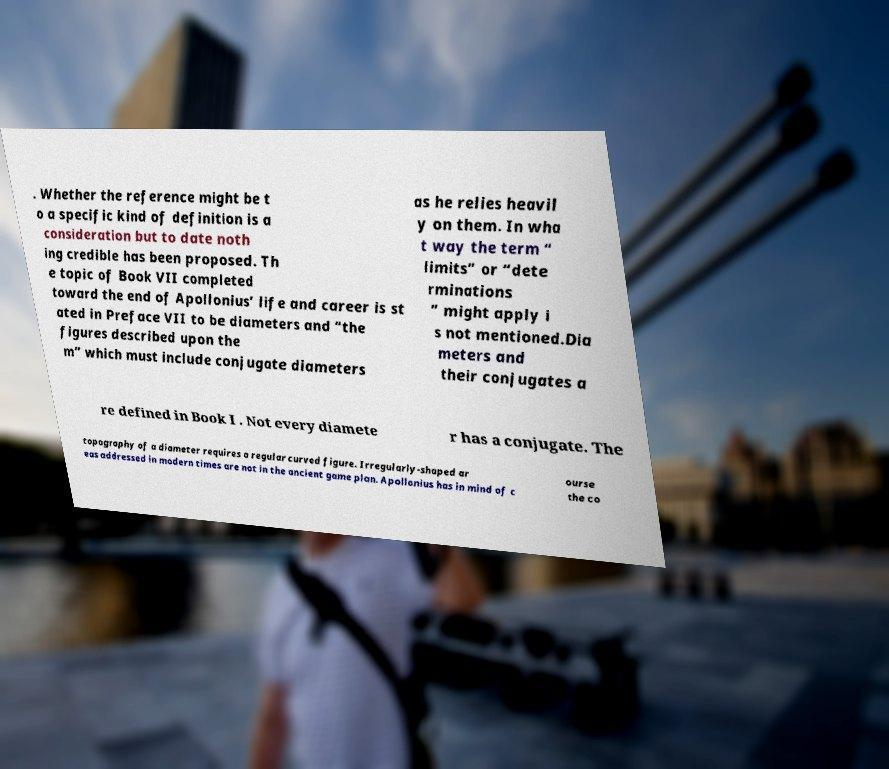Can you accurately transcribe the text from the provided image for me? . Whether the reference might be t o a specific kind of definition is a consideration but to date noth ing credible has been proposed. Th e topic of Book VII completed toward the end of Apollonius’ life and career is st ated in Preface VII to be diameters and “the figures described upon the m” which must include conjugate diameters as he relies heavil y on them. In wha t way the term “ limits” or “dete rminations ” might apply i s not mentioned.Dia meters and their conjugates a re defined in Book I . Not every diamete r has a conjugate. The topography of a diameter requires a regular curved figure. Irregularly-shaped ar eas addressed in modern times are not in the ancient game plan. Apollonius has in mind of c ourse the co 